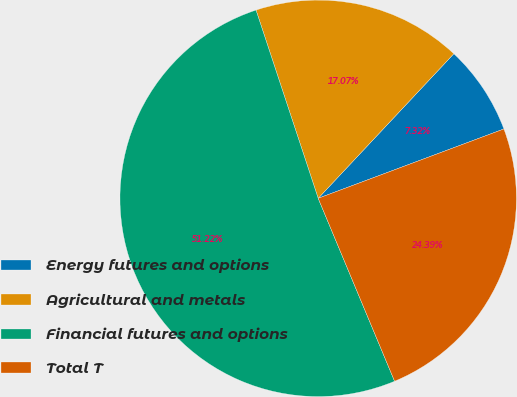<chart> <loc_0><loc_0><loc_500><loc_500><pie_chart><fcel>Energy futures and options<fcel>Agricultural and metals<fcel>Financial futures and options<fcel>Total T<nl><fcel>7.32%<fcel>17.07%<fcel>51.22%<fcel>24.39%<nl></chart> 